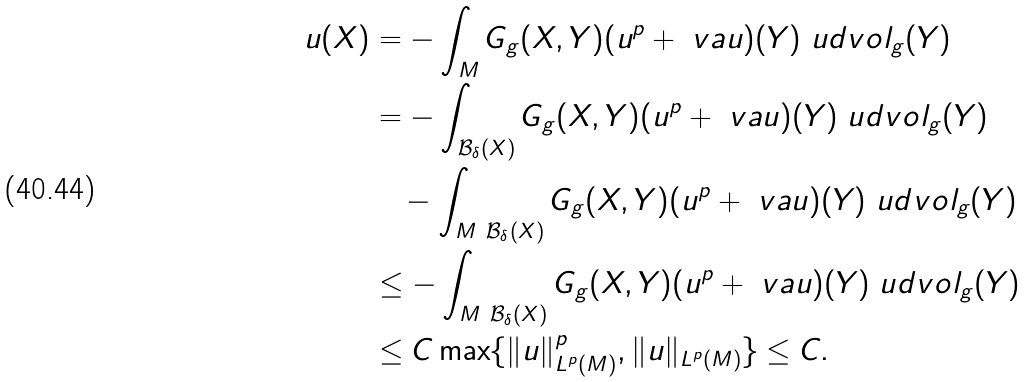<formula> <loc_0><loc_0><loc_500><loc_500>u ( X ) & = - \int _ { M } G _ { g } ( X , Y ) ( u ^ { p } + \ v a u ) ( Y ) \ u d v o l _ { g } ( Y ) \\ & = - \int _ { \mathcal { B } _ { \delta } ( X ) } G _ { g } ( X , Y ) ( u ^ { p } + \ v a u ) ( Y ) \ u d v o l _ { g } ( Y ) \\ & \quad - \int _ { M \ \mathcal { B } _ { \delta } ( X ) } G _ { g } ( X , Y ) ( u ^ { p } + \ v a u ) ( Y ) \ u d v o l _ { g } ( Y ) \\ & \leq - \int _ { M \ \mathcal { B } _ { \delta } ( X ) } G _ { g } ( X , Y ) ( u ^ { p } + \ v a u ) ( Y ) \ u d v o l _ { g } ( Y ) \\ & \leq C \max \{ \| u \| _ { L ^ { p } ( M ) } ^ { p } , \| u \| _ { L ^ { p } ( M ) } \} \leq C .</formula> 